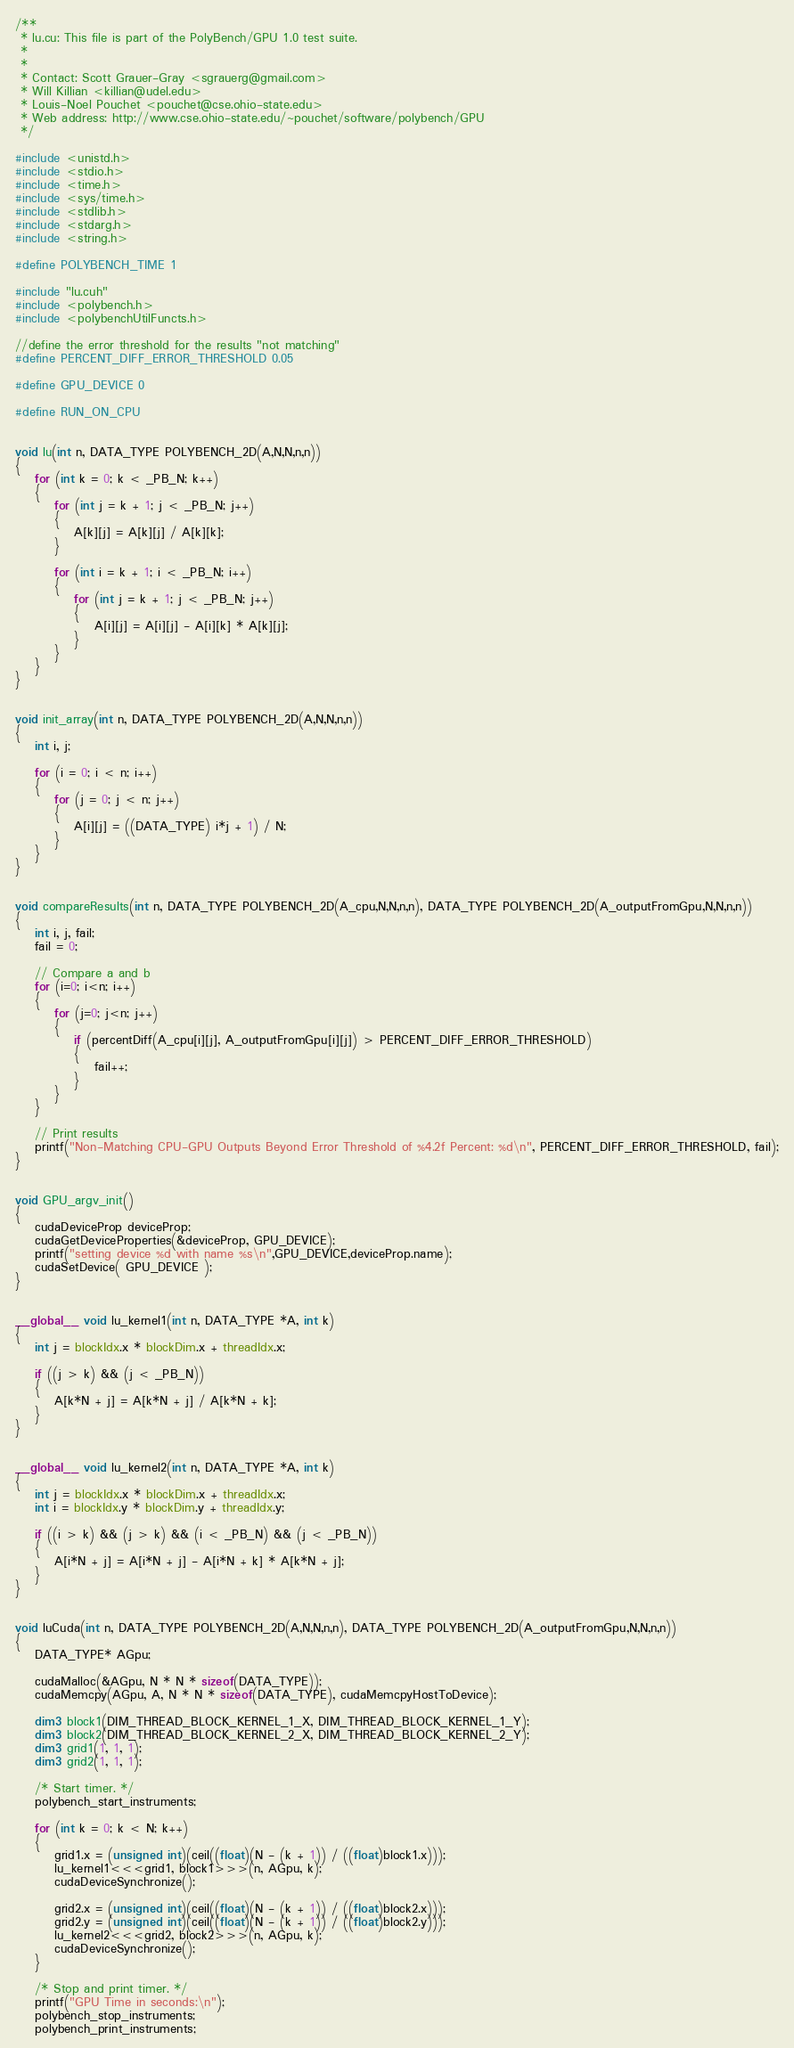<code> <loc_0><loc_0><loc_500><loc_500><_Cuda_>/**
 * lu.cu: This file is part of the PolyBench/GPU 1.0 test suite.
 *
 *
 * Contact: Scott Grauer-Gray <sgrauerg@gmail.com>
 * Will Killian <killian@udel.edu>
 * Louis-Noel Pouchet <pouchet@cse.ohio-state.edu>
 * Web address: http://www.cse.ohio-state.edu/~pouchet/software/polybench/GPU
 */

#include <unistd.h>
#include <stdio.h>
#include <time.h>
#include <sys/time.h>
#include <stdlib.h>
#include <stdarg.h>
#include <string.h>

#define POLYBENCH_TIME 1

#include "lu.cuh"
#include <polybench.h>
#include <polybenchUtilFuncts.h>

//define the error threshold for the results "not matching"
#define PERCENT_DIFF_ERROR_THRESHOLD 0.05

#define GPU_DEVICE 0

#define RUN_ON_CPU


void lu(int n, DATA_TYPE POLYBENCH_2D(A,N,N,n,n))
{
	for (int k = 0; k < _PB_N; k++)
    {
		for (int j = k + 1; j < _PB_N; j++)
		{
			A[k][j] = A[k][j] / A[k][k];
		}

		for (int i = k + 1; i < _PB_N; i++)
		{
			for (int j = k + 1; j < _PB_N; j++)
			{
				A[i][j] = A[i][j] - A[i][k] * A[k][j];
			}
		}
    }
}


void init_array(int n, DATA_TYPE POLYBENCH_2D(A,N,N,n,n))
{
	int i, j;

	for (i = 0; i < n; i++)
	{
		for (j = 0; j < n; j++)
		{
			A[i][j] = ((DATA_TYPE) i*j + 1) / N;
		}
	}
}


void compareResults(int n, DATA_TYPE POLYBENCH_2D(A_cpu,N,N,n,n), DATA_TYPE POLYBENCH_2D(A_outputFromGpu,N,N,n,n))
{
	int i, j, fail;
	fail = 0;
	
	// Compare a and b
	for (i=0; i<n; i++) 
	{
		for (j=0; j<n; j++) 
		{
			if (percentDiff(A_cpu[i][j], A_outputFromGpu[i][j]) > PERCENT_DIFF_ERROR_THRESHOLD) 
			{
				fail++;
			}
		}
	}
	
	// Print results
	printf("Non-Matching CPU-GPU Outputs Beyond Error Threshold of %4.2f Percent: %d\n", PERCENT_DIFF_ERROR_THRESHOLD, fail);
}


void GPU_argv_init()
{
	cudaDeviceProp deviceProp;
	cudaGetDeviceProperties(&deviceProp, GPU_DEVICE);
	printf("setting device %d with name %s\n",GPU_DEVICE,deviceProp.name);
	cudaSetDevice( GPU_DEVICE );
}


__global__ void lu_kernel1(int n, DATA_TYPE *A, int k)
{
	int j = blockIdx.x * blockDim.x + threadIdx.x;
	
	if ((j > k) && (j < _PB_N))
	{
		A[k*N + j] = A[k*N + j] / A[k*N + k];
	}
}


__global__ void lu_kernel2(int n, DATA_TYPE *A, int k)
{
	int j = blockIdx.x * blockDim.x + threadIdx.x;
	int i = blockIdx.y * blockDim.y + threadIdx.y;
	
	if ((i > k) && (j > k) && (i < _PB_N) && (j < _PB_N))
	{
		A[i*N + j] = A[i*N + j] - A[i*N + k] * A[k*N + j];
	}
}


void luCuda(int n, DATA_TYPE POLYBENCH_2D(A,N,N,n,n), DATA_TYPE POLYBENCH_2D(A_outputFromGpu,N,N,n,n))
{
	DATA_TYPE* AGpu;

	cudaMalloc(&AGpu, N * N * sizeof(DATA_TYPE));
	cudaMemcpy(AGpu, A, N * N * sizeof(DATA_TYPE), cudaMemcpyHostToDevice);

	dim3 block1(DIM_THREAD_BLOCK_KERNEL_1_X, DIM_THREAD_BLOCK_KERNEL_1_Y);
	dim3 block2(DIM_THREAD_BLOCK_KERNEL_2_X, DIM_THREAD_BLOCK_KERNEL_2_Y);
	dim3 grid1(1, 1, 1);
	dim3 grid2(1, 1, 1);

	/* Start timer. */
  	polybench_start_instruments;

	for (int k = 0; k < N; k++)
	{
		grid1.x = (unsigned int)(ceil((float)(N - (k + 1)) / ((float)block1.x)));
		lu_kernel1<<<grid1, block1>>>(n, AGpu, k);
		cudaDeviceSynchronize();

		grid2.x = (unsigned int)(ceil((float)(N - (k + 1)) / ((float)block2.x)));
		grid2.y = (unsigned int)(ceil((float)(N - (k + 1)) / ((float)block2.y)));
		lu_kernel2<<<grid2, block2>>>(n, AGpu, k);
		cudaDeviceSynchronize();
	}
	
	/* Stop and print timer. */
	printf("GPU Time in seconds:\n");
  	polybench_stop_instruments;
 	polybench_print_instruments;
</code> 